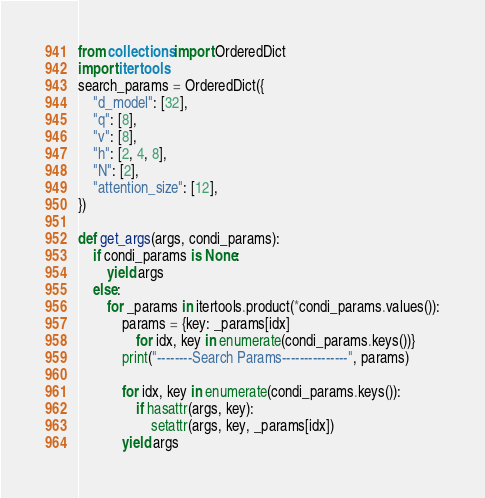<code> <loc_0><loc_0><loc_500><loc_500><_Python_>from collections import OrderedDict
import itertools
search_params = OrderedDict({
    "d_model": [32],
    "q": [8],
    "v": [8],
    "h": [2, 4, 8],
    "N": [2],
    "attention_size": [12],
})

def get_args(args, condi_params):
    if condi_params is None:
        yield args
    else:
        for _params in itertools.product(*condi_params.values()):
            params = {key: _params[idx]
                for idx, key in enumerate(condi_params.keys())}
            print("--------Search Params---------------", params)
            
            for idx, key in enumerate(condi_params.keys()):
                if hasattr(args, key):
                    setattr(args, key, _params[idx])
            yield args</code> 